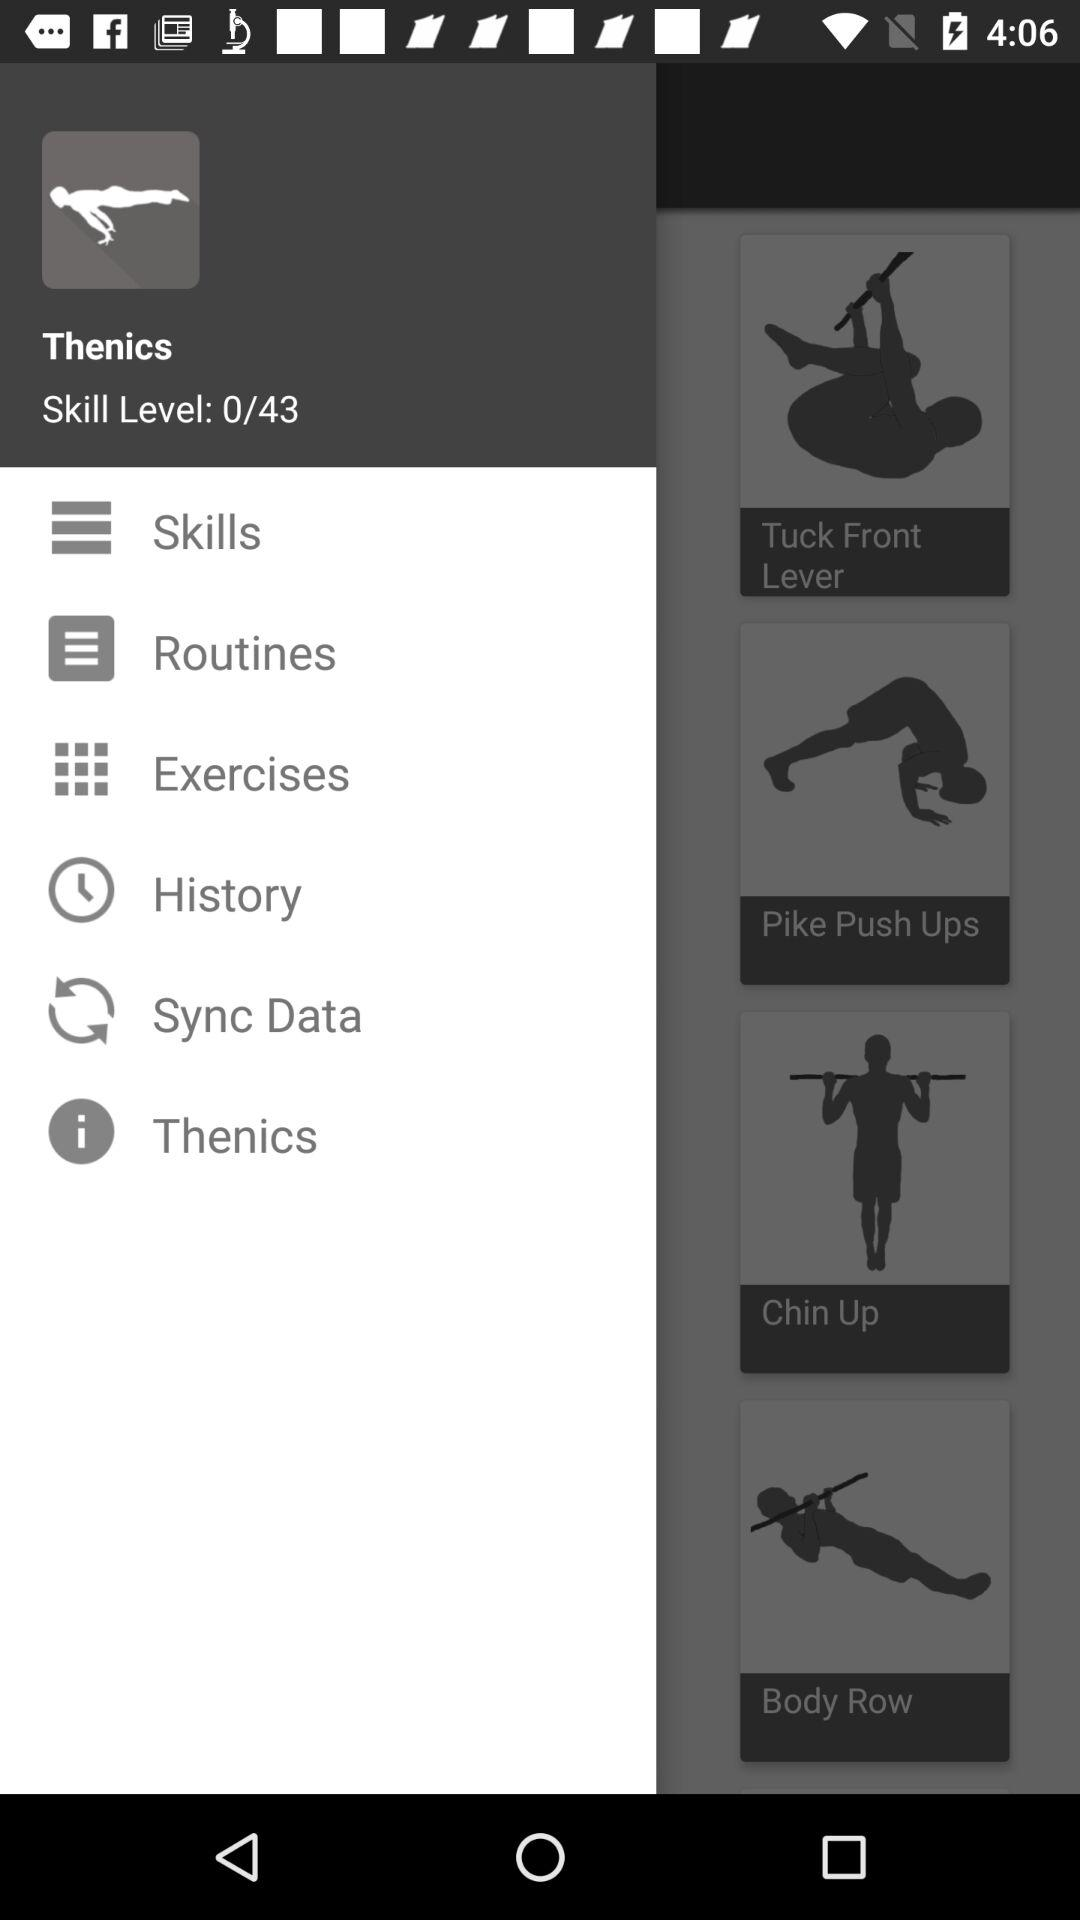What is the current skill level given? The current skill level given is 0. 